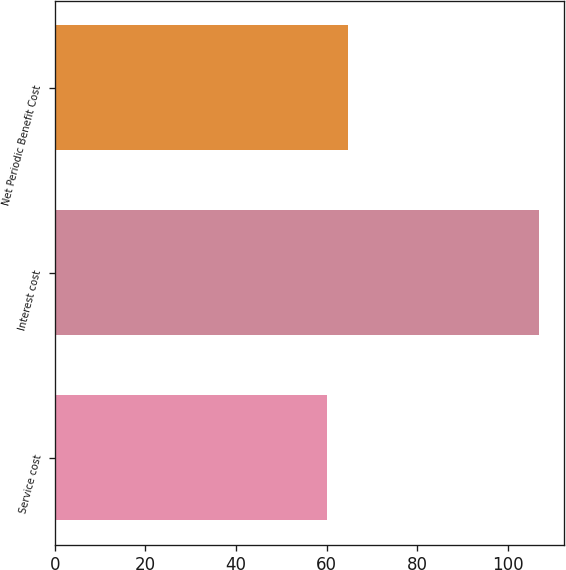<chart> <loc_0><loc_0><loc_500><loc_500><bar_chart><fcel>Service cost<fcel>Interest cost<fcel>Net Periodic Benefit Cost<nl><fcel>60<fcel>107<fcel>64.7<nl></chart> 